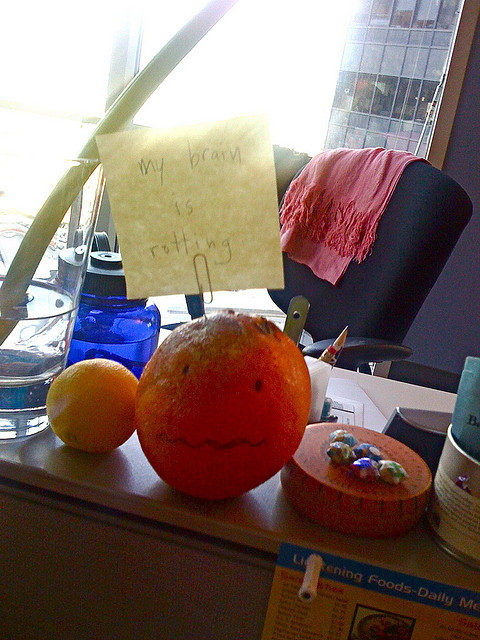Identify and read out the text in this image. my braiv is rotting Daily M B 